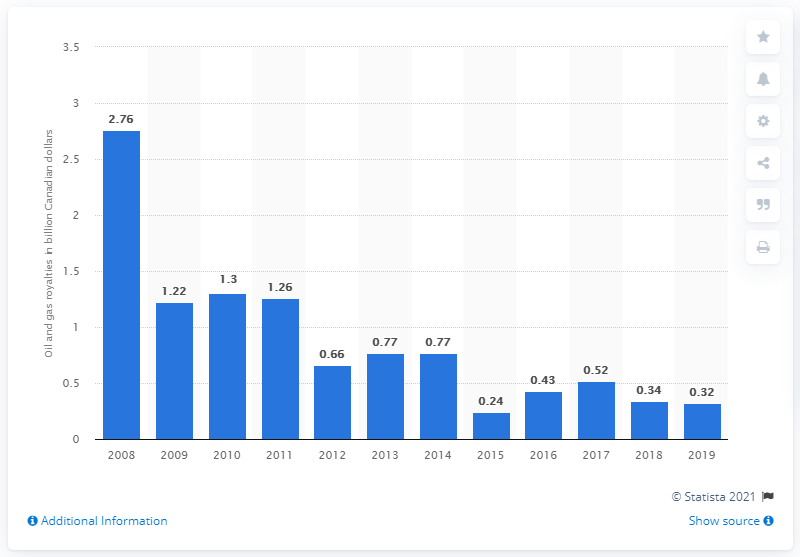Mention a couple of crucial points in this snapshot. In 2019, the federal government's oil and gas royalties amounted to approximately 0.32. 